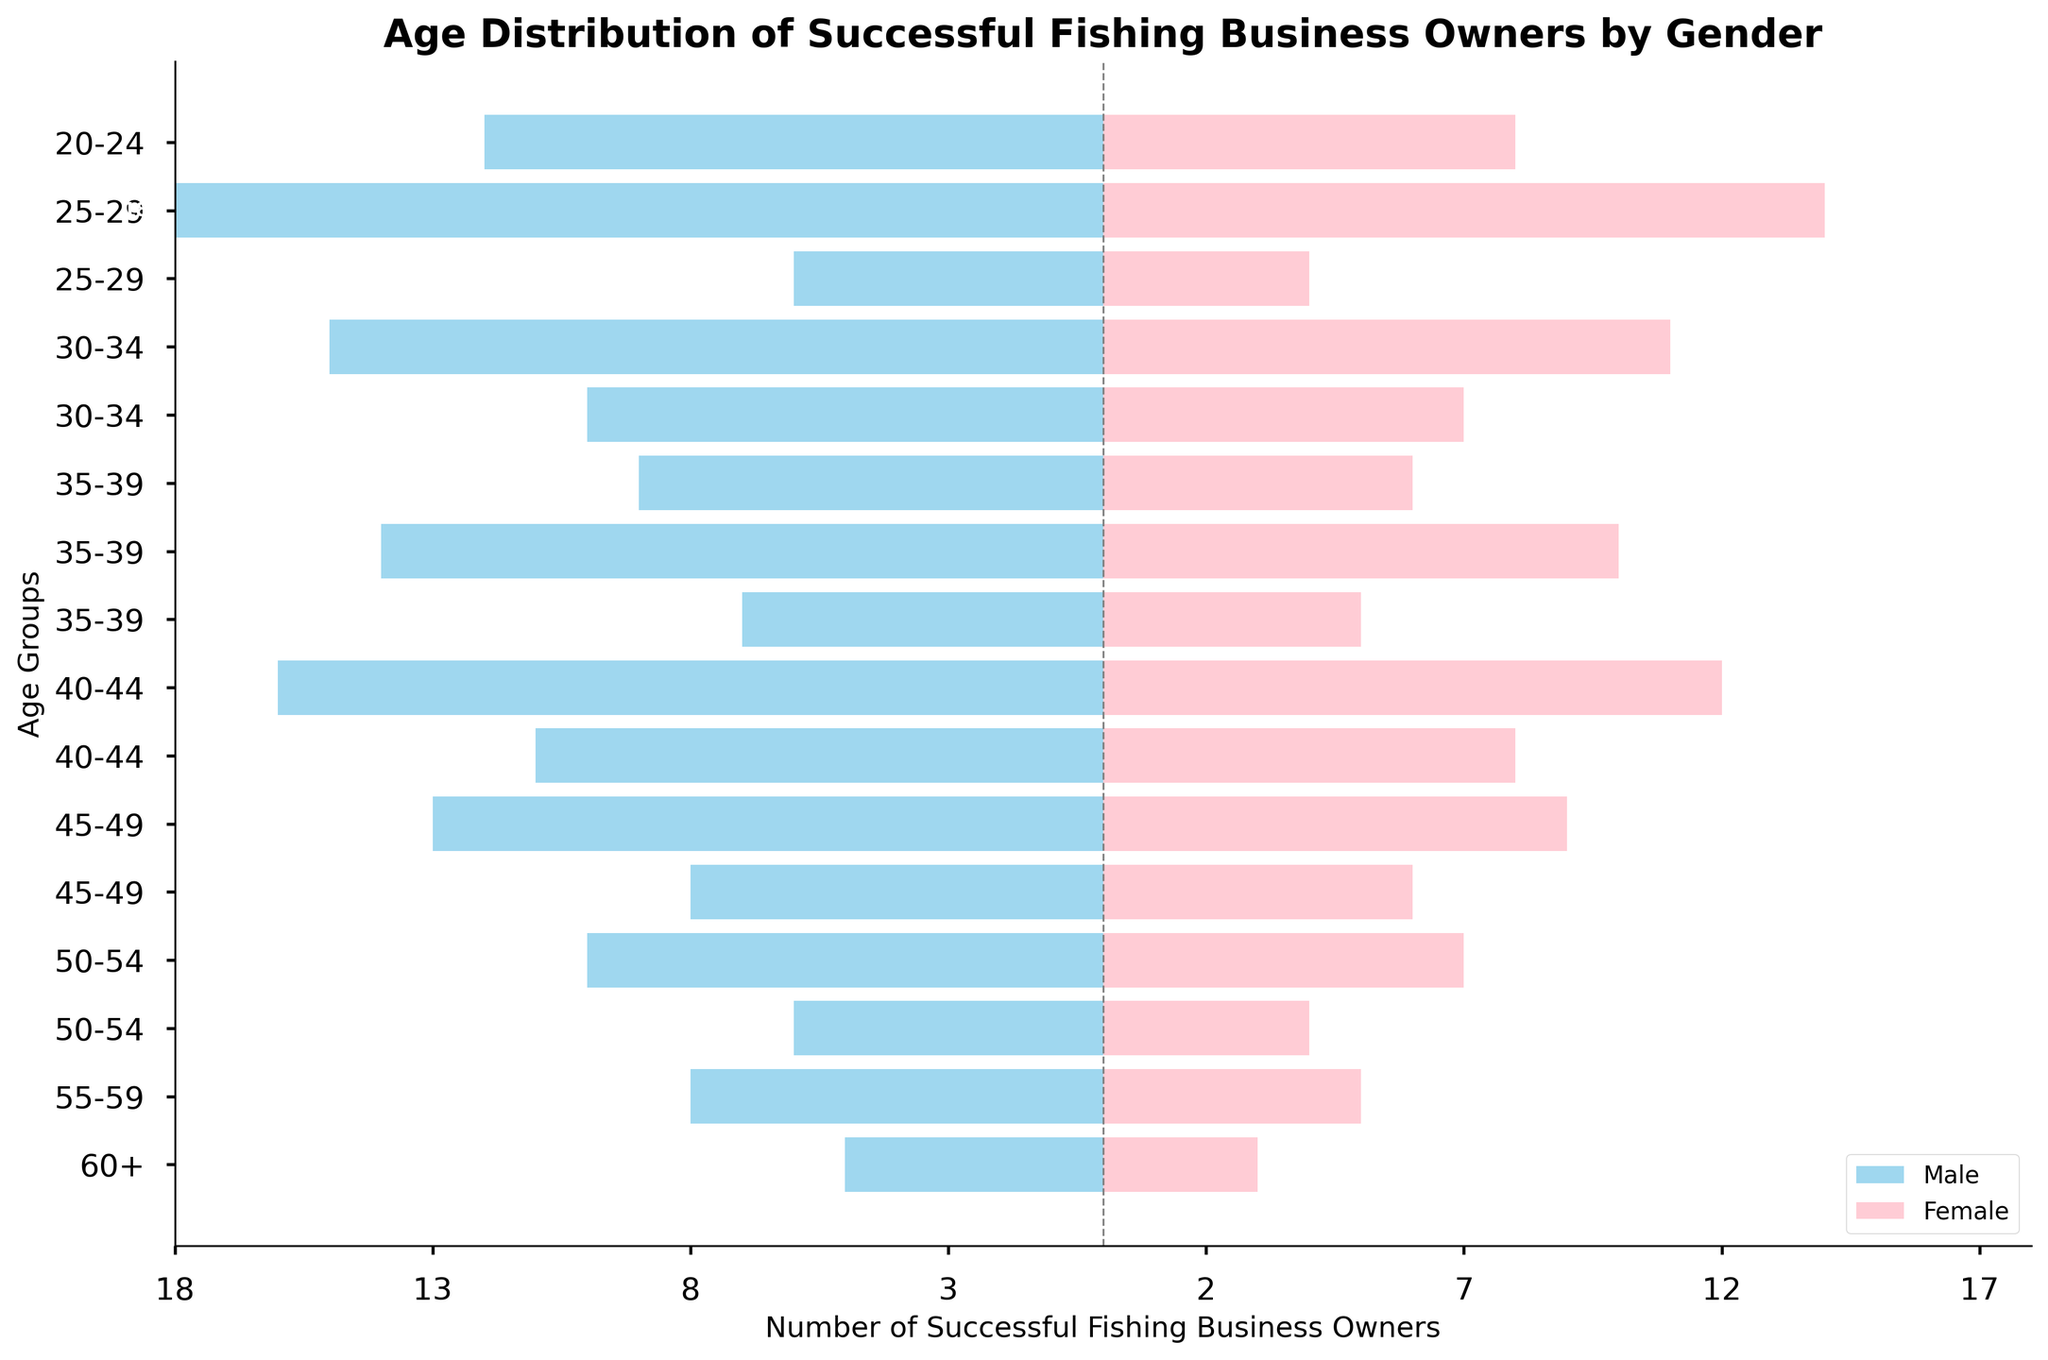What's the title of the figure? The title is displayed at the top of the chart and provides the overall summary of what the figure represents.
Answer: Age Distribution of Successful Fishing Business Owners by Gender How are age groups organized on the figure? Age groups are listed along the vertical axis (Y-axis) from youngest at the top to oldest at the bottom.
Answer: From youngest to oldest What does the pink color represent in the chart? The legend at the bottom right corner of the figure indicates that the pink color represents Female successful fishing business owners.
Answer: Female Which gender has more successful fishing business owners in the 25-29 age group with 0-5 years of experience? In the 25-29 age group with 0-5 years of experience, the bar lengths indicate that there are 18 males and 14 females. Comparing these counts, males have more successful owners.
Answer: Male What age group has the highest number of successful female fishing business owners? By comparing the lengths of the pink bars, the age group with the highest number of successful female business owners can be identified. The 25-29 (0-5) age group has the longest pink bar, showing 14 female owners.
Answer: 25-29 (0-5 years) In the 35-39 age group, how many successful fishing business owners have 6-10 years of experience? Sum the male and female values for the 35-39 age group with 6-10 years of experience: 14 (males) + 10 (females).
Answer: 24 Which age groups have more male owners than female owners? For each age group, compare the lengths of the skyblue bars (male) to the pink bars (female). The age groups where males exceed females are all groups except 55-59 (21+ years), where females (5) exceed males (8).
Answer: All except 55-59 (21+) What's the difference in the number of successful business owners between males and females in the 45-49 age group with 11-15 years of experience? For the 45-49 age group with 11-15 years of experience: 13 (males) - 9 (females), the difference is 4.
Answer: 4 Which age group has the lowest number of successful fishing business owners and what is the total count? Sum the values for both genders in each age group and identify the lowest total. The 60+ age group (21+ years) has 5 (males) + 3 (females) = 8, which is the smallest total.
Answer: 60+ (8) Is there an age group where females dominate males? By comparing the values for each age group, we see that in the 55-59 (21+ years) age group, females (5) dominate compared to males (8).
Answer: No 